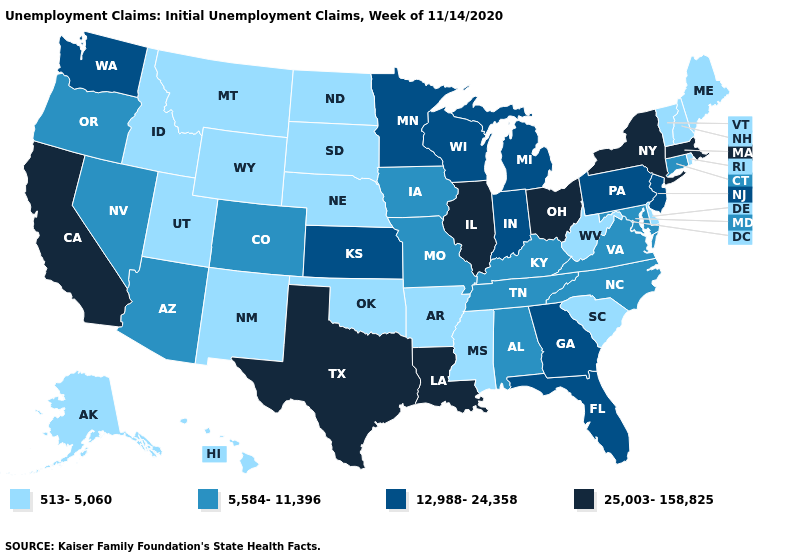Which states have the lowest value in the USA?
Concise answer only. Alaska, Arkansas, Delaware, Hawaii, Idaho, Maine, Mississippi, Montana, Nebraska, New Hampshire, New Mexico, North Dakota, Oklahoma, Rhode Island, South Carolina, South Dakota, Utah, Vermont, West Virginia, Wyoming. Among the states that border Iowa , does South Dakota have the lowest value?
Be succinct. Yes. Does South Dakota have the highest value in the MidWest?
Concise answer only. No. What is the lowest value in the Northeast?
Keep it brief. 513-5,060. Does Pennsylvania have the same value as Georgia?
Quick response, please. Yes. Name the states that have a value in the range 25,003-158,825?
Concise answer only. California, Illinois, Louisiana, Massachusetts, New York, Ohio, Texas. Does South Dakota have the lowest value in the MidWest?
Concise answer only. Yes. Does New Mexico have the highest value in the USA?
Concise answer only. No. Name the states that have a value in the range 513-5,060?
Concise answer only. Alaska, Arkansas, Delaware, Hawaii, Idaho, Maine, Mississippi, Montana, Nebraska, New Hampshire, New Mexico, North Dakota, Oklahoma, Rhode Island, South Carolina, South Dakota, Utah, Vermont, West Virginia, Wyoming. Among the states that border Indiana , does Michigan have the lowest value?
Give a very brief answer. No. Name the states that have a value in the range 12,988-24,358?
Concise answer only. Florida, Georgia, Indiana, Kansas, Michigan, Minnesota, New Jersey, Pennsylvania, Washington, Wisconsin. Among the states that border Alabama , which have the lowest value?
Short answer required. Mississippi. Name the states that have a value in the range 12,988-24,358?
Quick response, please. Florida, Georgia, Indiana, Kansas, Michigan, Minnesota, New Jersey, Pennsylvania, Washington, Wisconsin. Does New Hampshire have the highest value in the Northeast?
Quick response, please. No. Which states have the lowest value in the USA?
Quick response, please. Alaska, Arkansas, Delaware, Hawaii, Idaho, Maine, Mississippi, Montana, Nebraska, New Hampshire, New Mexico, North Dakota, Oklahoma, Rhode Island, South Carolina, South Dakota, Utah, Vermont, West Virginia, Wyoming. 